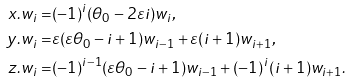Convert formula to latex. <formula><loc_0><loc_0><loc_500><loc_500>x . w _ { i } = & ( - 1 ) ^ { i } ( \theta _ { 0 } - 2 \varepsilon i ) w _ { i } , \\ y . w _ { i } = & \varepsilon ( \varepsilon \theta _ { 0 } - i + 1 ) w _ { i - 1 } + \varepsilon ( i + 1 ) w _ { i + 1 } , \\ z . w _ { i } = & ( - 1 ) ^ { i - 1 } ( \varepsilon \theta _ { 0 } - i + 1 ) w _ { i - 1 } + ( - 1 ) ^ { i } ( i + 1 ) w _ { i + 1 } .</formula> 